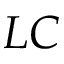<formula> <loc_0><loc_0><loc_500><loc_500>L C</formula> 